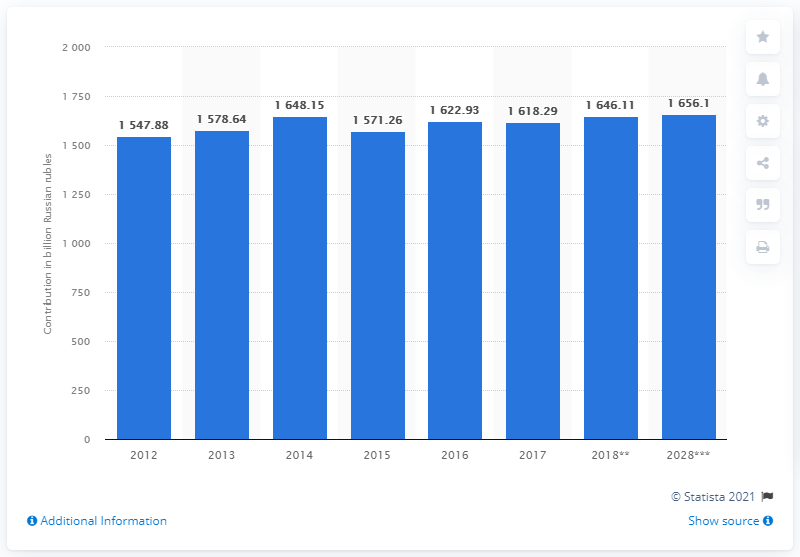Indicate a few pertinent items in this graphic. In 2019, the travel and tourism industry contributed 1656.1 rubles to the gross domestic product (GDP) of Russia. 